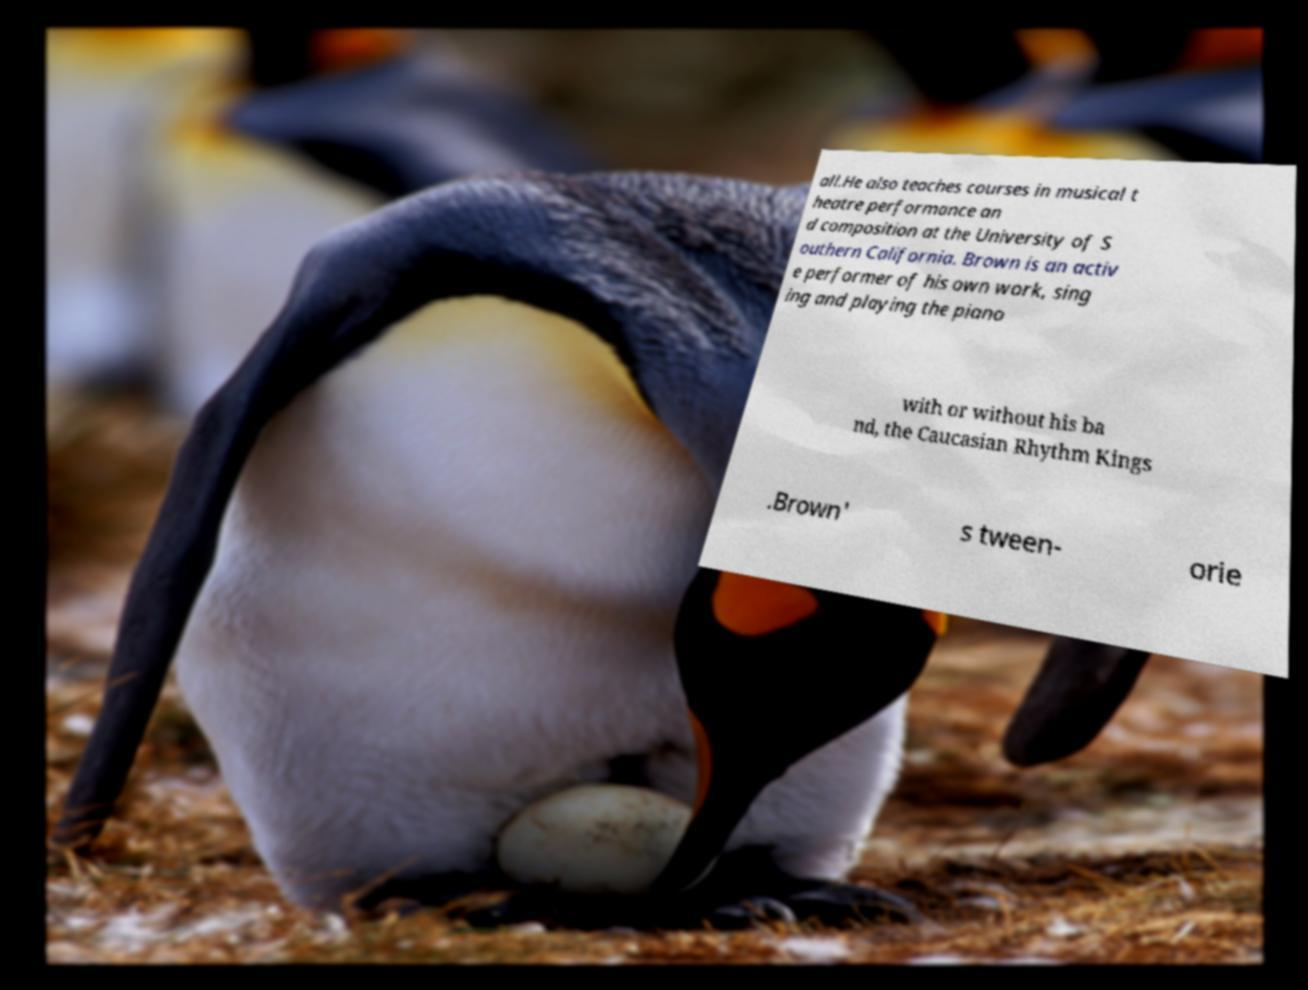Could you extract and type out the text from this image? all.He also teaches courses in musical t heatre performance an d composition at the University of S outhern California. Brown is an activ e performer of his own work, sing ing and playing the piano with or without his ba nd, the Caucasian Rhythm Kings .Brown' s tween- orie 